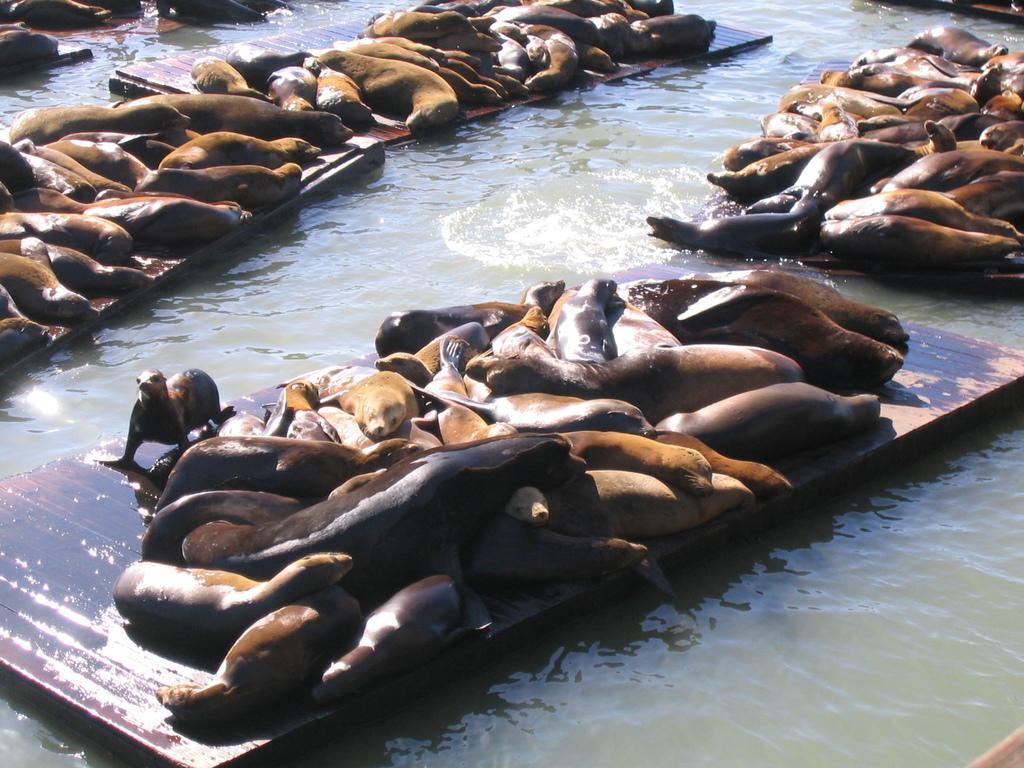Could you give a brief overview of what you see in this image? In the image we can see some water, on the water there are some seals on wooden sticks. 